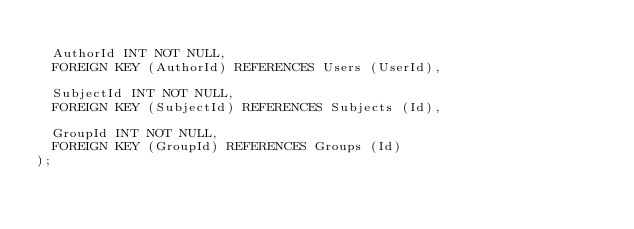Convert code to text. <code><loc_0><loc_0><loc_500><loc_500><_SQL_>
	AuthorId INT NOT NULL,
	FOREIGN KEY (AuthorId) REFERENCES Users (UserId),

	SubjectId INT NOT NULL,
	FOREIGN KEY (SubjectId) REFERENCES Subjects (Id),

	GroupId INT NOT NULL,
	FOREIGN KEY (GroupId) REFERENCES Groups (Id)
);</code> 